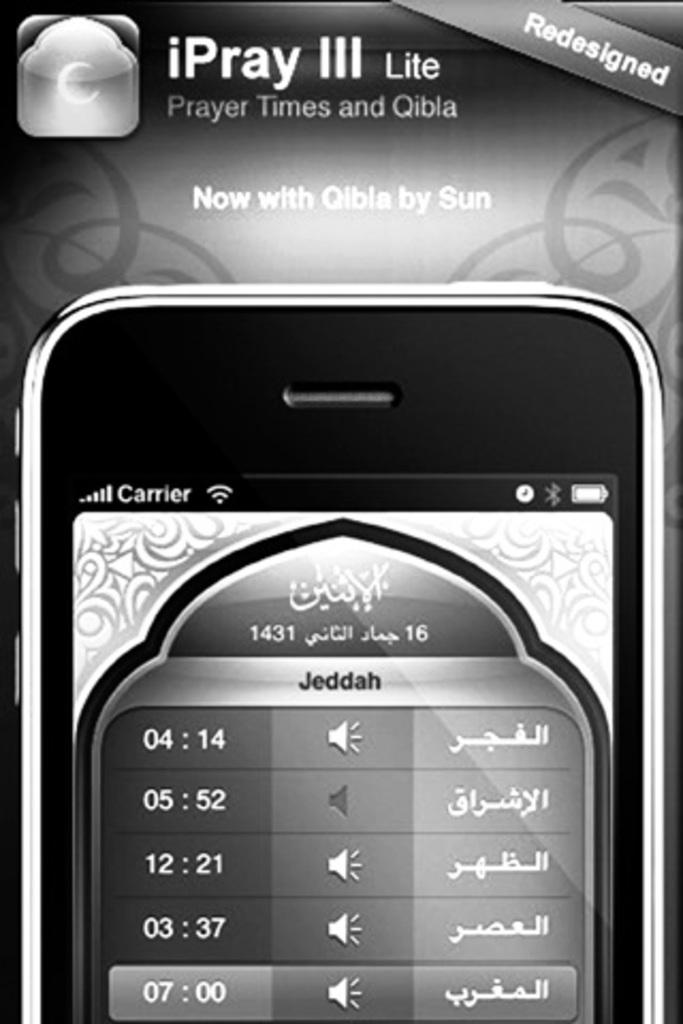<image>
Relay a brief, clear account of the picture shown. A screenshot of a phone with Lite at the top. 